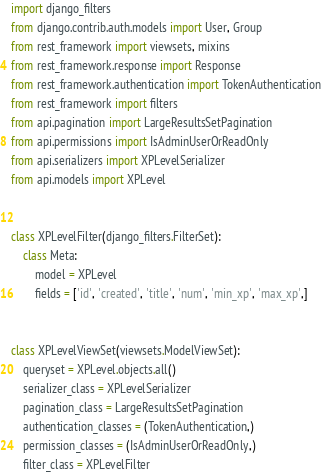Convert code to text. <code><loc_0><loc_0><loc_500><loc_500><_Python_>import django_filters
from django.contrib.auth.models import User, Group
from rest_framework import viewsets, mixins
from rest_framework.response import Response
from rest_framework.authentication import TokenAuthentication
from rest_framework import filters
from api.pagination import LargeResultsSetPagination
from api.permissions import IsAdminUserOrReadOnly
from api.serializers import XPLevelSerializer
from api.models import XPLevel


class XPLevelFilter(django_filters.FilterSet):
    class Meta:
        model = XPLevel
        fields = ['id', 'created', 'title', 'num', 'min_xp', 'max_xp',]


class XPLevelViewSet(viewsets.ModelViewSet):
    queryset = XPLevel.objects.all()
    serializer_class = XPLevelSerializer
    pagination_class = LargeResultsSetPagination
    authentication_classes = (TokenAuthentication,)
    permission_classes = (IsAdminUserOrReadOnly,)
    filter_class = XPLevelFilter
</code> 